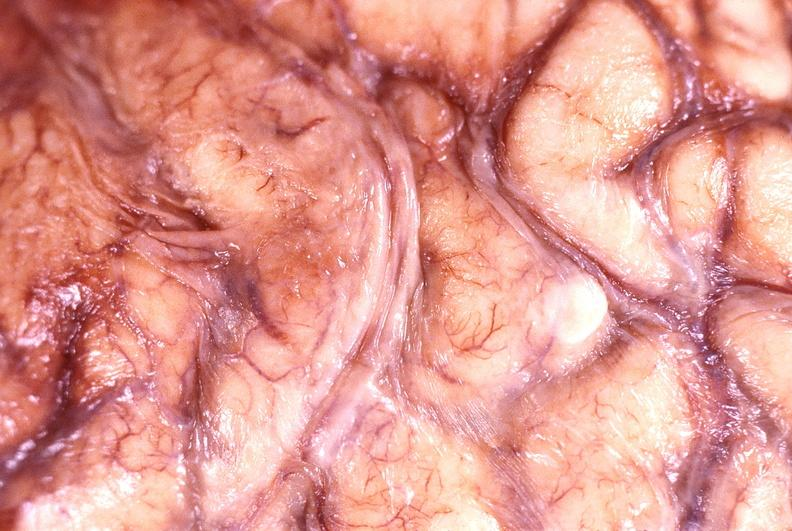s cleft palate present?
Answer the question using a single word or phrase. No 